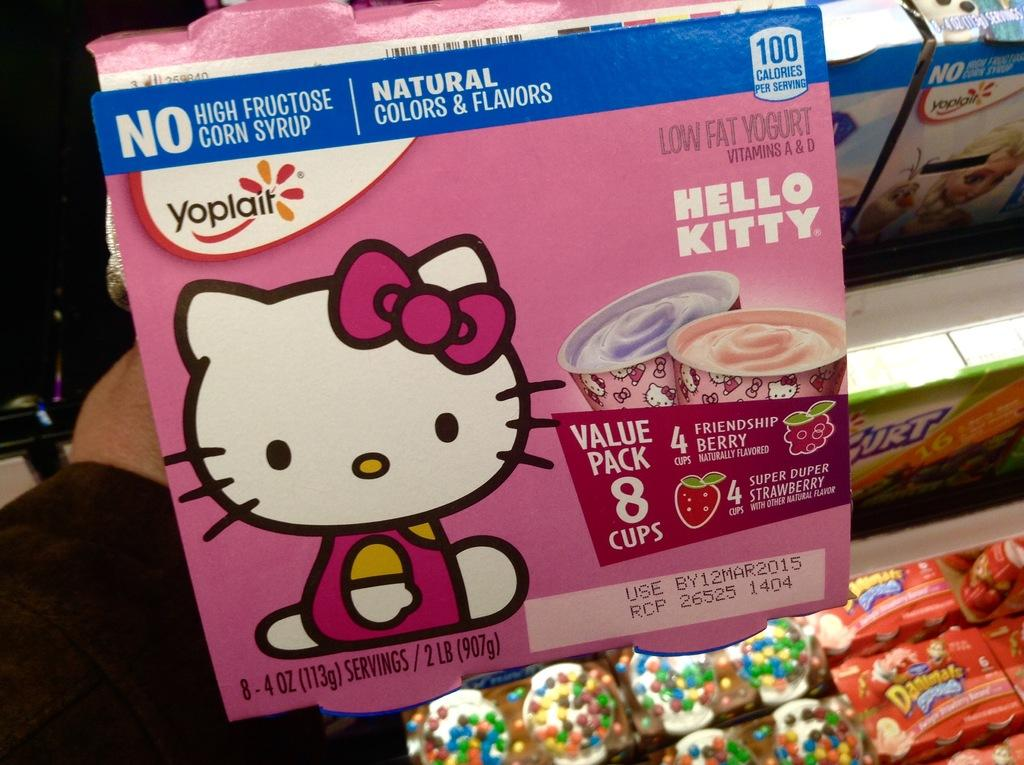What is inside the box that is being held by a person in the image? There is food packed in a box in the image. Who is holding the box in the image? A person is holding the box in the image. What can be seen on the shelf in the image? There are chocolates arranged on a shelf in the image. Can you tell me how many oranges are on the shelf next to the chocolates in the image? There are no oranges present in the image; only chocolates are arranged on the shelf. What advice would the person's mother give them about holding the box in the image? There is no reference to a mother or any advice in the image, so it is not possible to answer that question. 